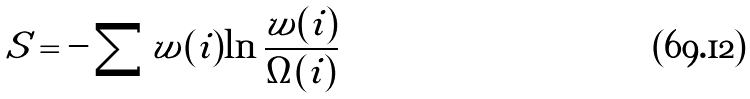<formula> <loc_0><loc_0><loc_500><loc_500>S = - \sum w ( i ) \ln \frac { w ( i ) } { \Omega ( i ) }</formula> 